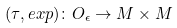<formula> <loc_0><loc_0><loc_500><loc_500>( \tau , e x p ) \colon O _ { \epsilon } \to M \times M</formula> 